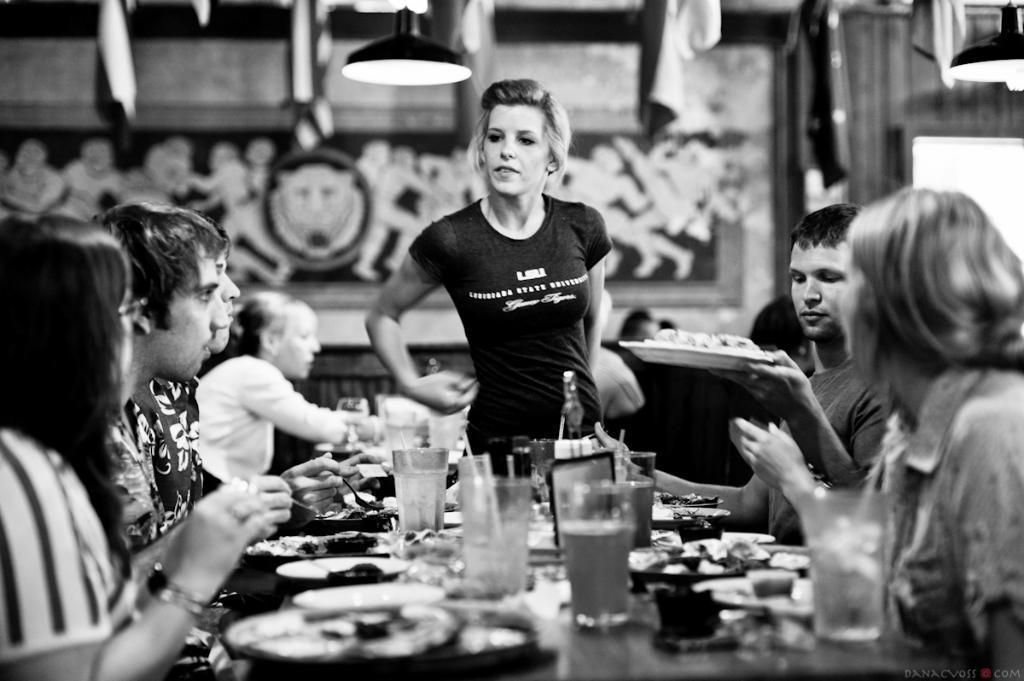Could you give a brief overview of what you see in this image? Here in this picture we can see a group of people sitting on chairs having their meal and the woman in the center is standing and we have glasses of juices on the table and there is food on the plates 